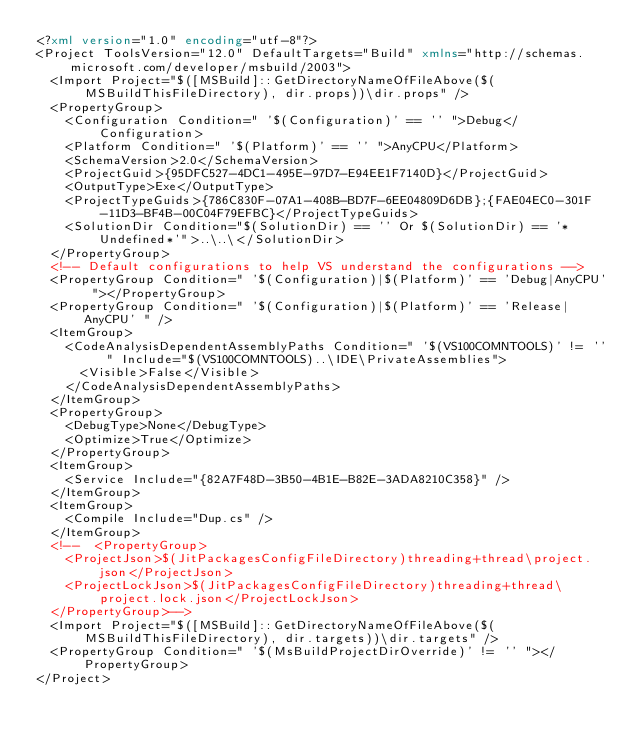Convert code to text. <code><loc_0><loc_0><loc_500><loc_500><_XML_><?xml version="1.0" encoding="utf-8"?>
<Project ToolsVersion="12.0" DefaultTargets="Build" xmlns="http://schemas.microsoft.com/developer/msbuild/2003">
  <Import Project="$([MSBuild]::GetDirectoryNameOfFileAbove($(MSBuildThisFileDirectory), dir.props))\dir.props" />
  <PropertyGroup>
    <Configuration Condition=" '$(Configuration)' == '' ">Debug</Configuration>
    <Platform Condition=" '$(Platform)' == '' ">AnyCPU</Platform>
    <SchemaVersion>2.0</SchemaVersion>
    <ProjectGuid>{95DFC527-4DC1-495E-97D7-E94EE1F7140D}</ProjectGuid>
    <OutputType>Exe</OutputType>
    <ProjectTypeGuids>{786C830F-07A1-408B-BD7F-6EE04809D6DB};{FAE04EC0-301F-11D3-BF4B-00C04F79EFBC}</ProjectTypeGuids>
    <SolutionDir Condition="$(SolutionDir) == '' Or $(SolutionDir) == '*Undefined*'">..\..\</SolutionDir>
  </PropertyGroup>
  <!-- Default configurations to help VS understand the configurations -->
  <PropertyGroup Condition=" '$(Configuration)|$(Platform)' == 'Debug|AnyCPU' "></PropertyGroup>
  <PropertyGroup Condition=" '$(Configuration)|$(Platform)' == 'Release|AnyCPU' " />
  <ItemGroup>
    <CodeAnalysisDependentAssemblyPaths Condition=" '$(VS100COMNTOOLS)' != '' " Include="$(VS100COMNTOOLS)..\IDE\PrivateAssemblies">
      <Visible>False</Visible>
    </CodeAnalysisDependentAssemblyPaths>
  </ItemGroup>
  <PropertyGroup>
    <DebugType>None</DebugType>
    <Optimize>True</Optimize>
  </PropertyGroup>
  <ItemGroup>
    <Service Include="{82A7F48D-3B50-4B1E-B82E-3ADA8210C358}" />
  </ItemGroup>
  <ItemGroup>
    <Compile Include="Dup.cs" />
  </ItemGroup>
  <!--  <PropertyGroup>
    <ProjectJson>$(JitPackagesConfigFileDirectory)threading+thread\project.json</ProjectJson>
    <ProjectLockJson>$(JitPackagesConfigFileDirectory)threading+thread\project.lock.json</ProjectLockJson>
  </PropertyGroup>-->
  <Import Project="$([MSBuild]::GetDirectoryNameOfFileAbove($(MSBuildThisFileDirectory), dir.targets))\dir.targets" />
  <PropertyGroup Condition=" '$(MsBuildProjectDirOverride)' != '' "></PropertyGroup>
</Project></code> 